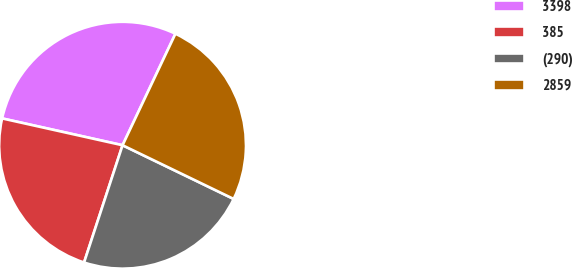Convert chart to OTSL. <chart><loc_0><loc_0><loc_500><loc_500><pie_chart><fcel>3398<fcel>385<fcel>(290)<fcel>2859<nl><fcel>28.56%<fcel>23.44%<fcel>22.88%<fcel>25.12%<nl></chart> 